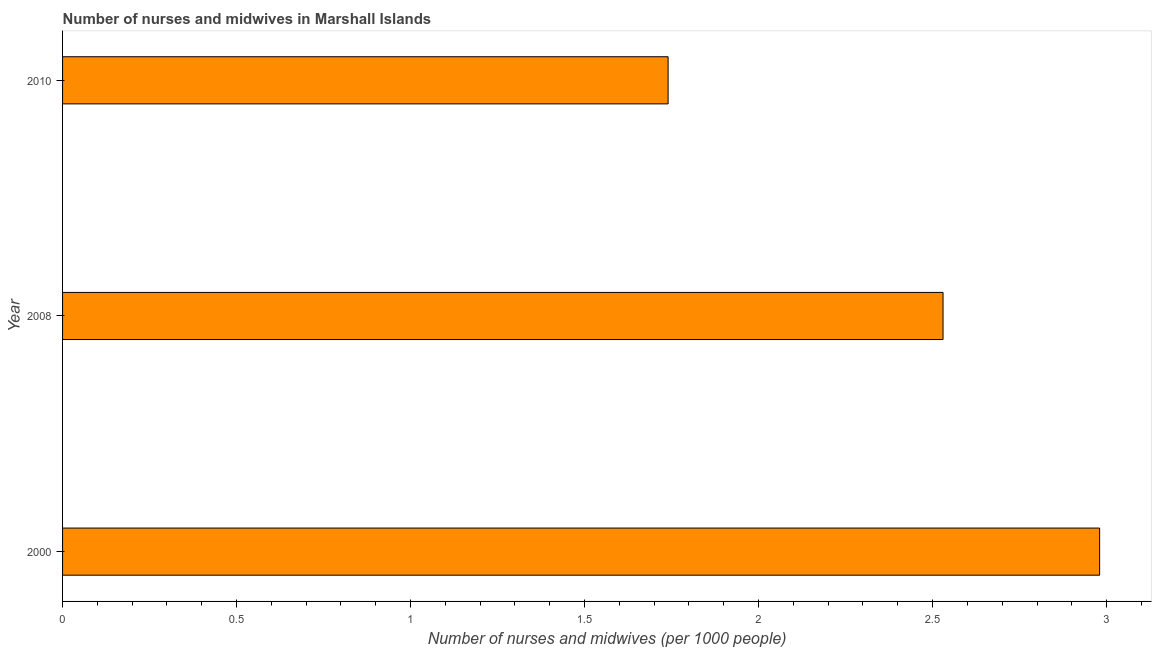Does the graph contain any zero values?
Ensure brevity in your answer.  No. What is the title of the graph?
Keep it short and to the point. Number of nurses and midwives in Marshall Islands. What is the label or title of the X-axis?
Give a very brief answer. Number of nurses and midwives (per 1000 people). What is the label or title of the Y-axis?
Provide a succinct answer. Year. What is the number of nurses and midwives in 2010?
Ensure brevity in your answer.  1.74. Across all years, what is the maximum number of nurses and midwives?
Provide a succinct answer. 2.98. Across all years, what is the minimum number of nurses and midwives?
Offer a terse response. 1.74. In which year was the number of nurses and midwives maximum?
Your response must be concise. 2000. What is the sum of the number of nurses and midwives?
Offer a terse response. 7.25. What is the difference between the number of nurses and midwives in 2000 and 2008?
Your response must be concise. 0.45. What is the average number of nurses and midwives per year?
Offer a terse response. 2.42. What is the median number of nurses and midwives?
Offer a terse response. 2.53. In how many years, is the number of nurses and midwives greater than 1.4 ?
Your answer should be compact. 3. What is the ratio of the number of nurses and midwives in 2008 to that in 2010?
Make the answer very short. 1.45. What is the difference between the highest and the second highest number of nurses and midwives?
Ensure brevity in your answer.  0.45. What is the difference between the highest and the lowest number of nurses and midwives?
Provide a short and direct response. 1.24. In how many years, is the number of nurses and midwives greater than the average number of nurses and midwives taken over all years?
Provide a short and direct response. 2. How many bars are there?
Provide a succinct answer. 3. Are all the bars in the graph horizontal?
Offer a terse response. Yes. How many years are there in the graph?
Make the answer very short. 3. What is the Number of nurses and midwives (per 1000 people) in 2000?
Provide a short and direct response. 2.98. What is the Number of nurses and midwives (per 1000 people) in 2008?
Provide a succinct answer. 2.53. What is the Number of nurses and midwives (per 1000 people) in 2010?
Offer a very short reply. 1.74. What is the difference between the Number of nurses and midwives (per 1000 people) in 2000 and 2008?
Offer a very short reply. 0.45. What is the difference between the Number of nurses and midwives (per 1000 people) in 2000 and 2010?
Your answer should be compact. 1.24. What is the difference between the Number of nurses and midwives (per 1000 people) in 2008 and 2010?
Your answer should be compact. 0.79. What is the ratio of the Number of nurses and midwives (per 1000 people) in 2000 to that in 2008?
Give a very brief answer. 1.18. What is the ratio of the Number of nurses and midwives (per 1000 people) in 2000 to that in 2010?
Keep it short and to the point. 1.71. What is the ratio of the Number of nurses and midwives (per 1000 people) in 2008 to that in 2010?
Your answer should be compact. 1.45. 